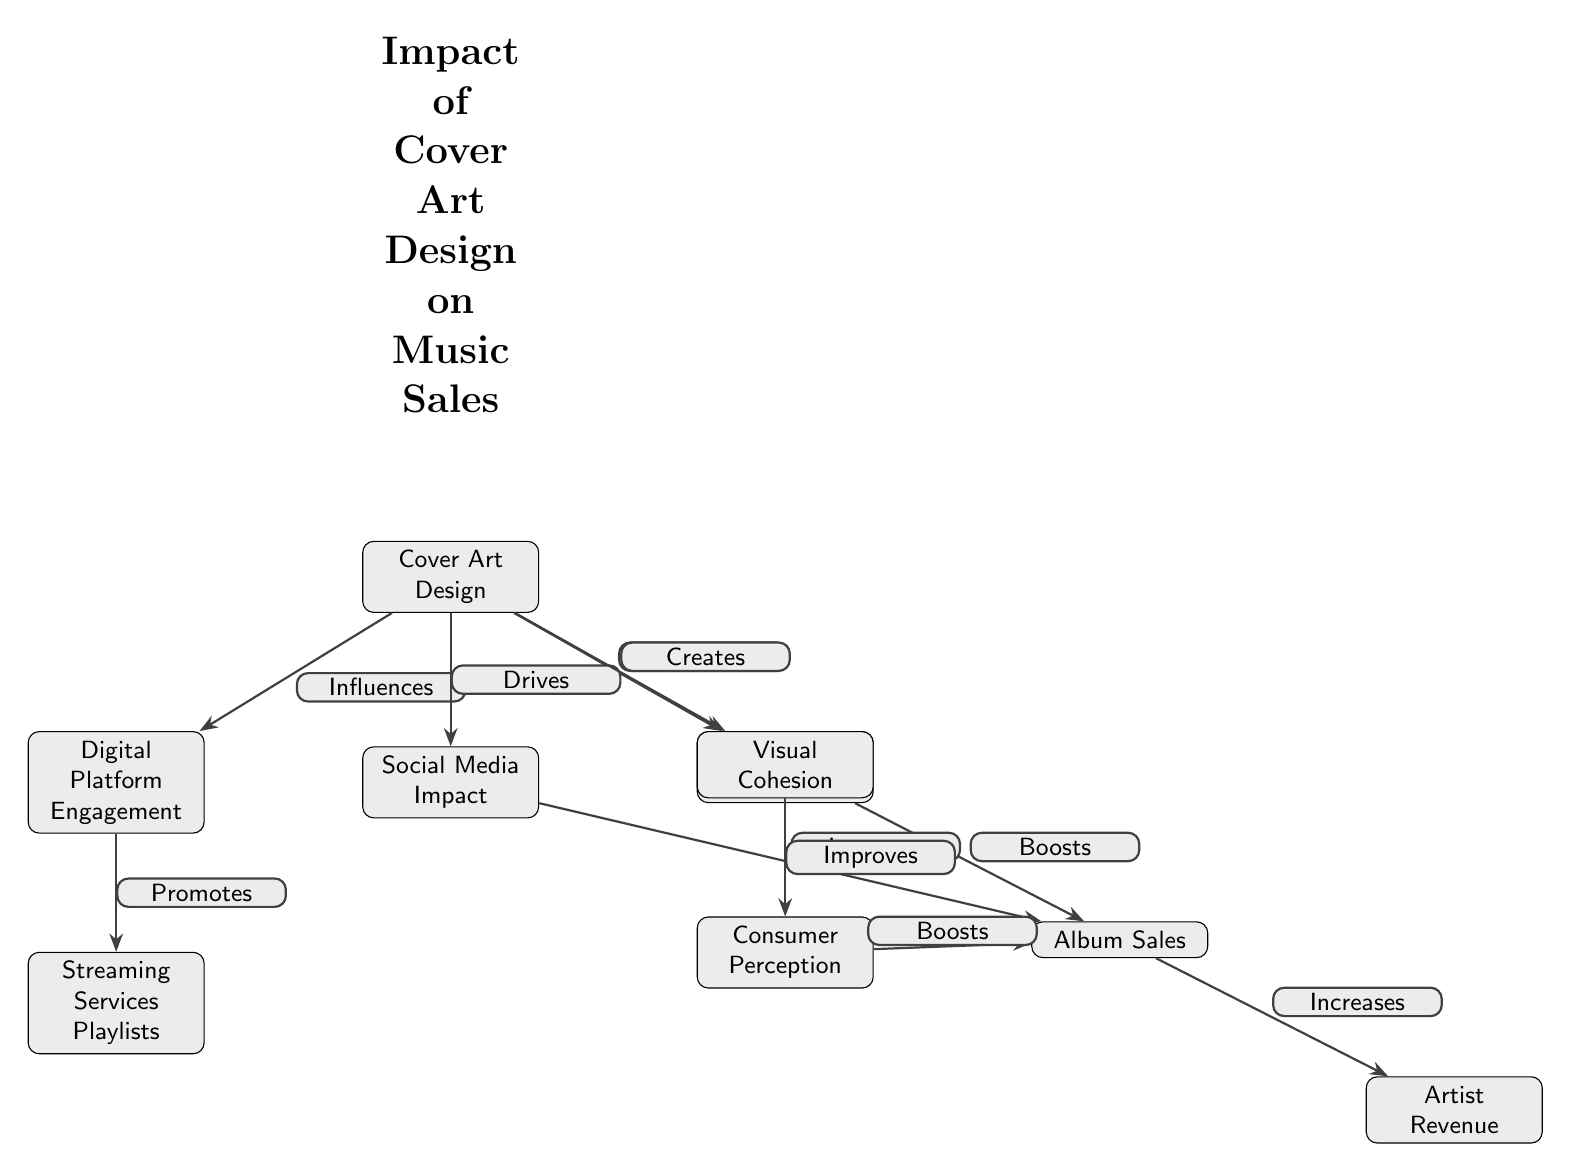What is the primary focus of the diagram? The diagram centers on how Cover Art Design impacts various aspects of music sales, linking it to branding, engagement, and revenue.
Answer: Cover Art Design How many nodes are in the diagram? Counting all the distinct nodes present in the diagram gives us a total of 9 nodes that represent different concepts.
Answer: 9 What relationship does Cover Art Design have with Visual Cohesion? The edge indicates that Cover Art Design "Creates" Visual Cohesion, highlighting its role in establishing a visually unified representation.
Answer: Creates Which node directly influences Artist Revenue? The diagram shows that Album Sales is the node that directly influences Artist Revenue, demonstrating a clear financial connection.
Answer: Album Sales What type of impact does Social Media have on Album Sales? According to the diagram, Social Media impacts Album Sales by "Increases," indicating a positive contribution to sales.
Answer: Increases In what way does Cover Art Design affect Digital Platform Engagement? The diagram states that Cover Art Design "Influences" Digital Platform Engagement, suggesting that the design plays a crucial role in attracting engagement on digital platforms.
Answer: Influences How does Consumer Perception relate to Album Sales? The flow from Consumer Perception to Album Sales indicates that improvements in perception lead to higher sales figures, as shown by "Boosts."
Answer: Boosts According to the diagram, what role does Streaming Services Playlists play? Streaming Services Playlists are promoted as a result of Digital Platform Engagement, showing that they are directly linked to audience engagement through these services.
Answer: Promotes What does Visual Cohesion improve according to the diagram? The diagram specifies that Visual Cohesion "Improves" Consumer Perception, revealing how cohesive design can enhance how consumers view the music.
Answer: Improves 